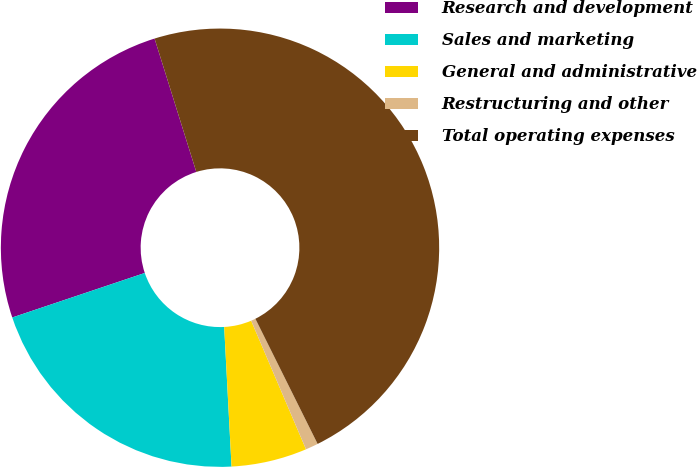Convert chart. <chart><loc_0><loc_0><loc_500><loc_500><pie_chart><fcel>Research and development<fcel>Sales and marketing<fcel>General and administrative<fcel>Restructuring and other<fcel>Total operating expenses<nl><fcel>25.33%<fcel>20.68%<fcel>5.58%<fcel>0.93%<fcel>47.48%<nl></chart> 